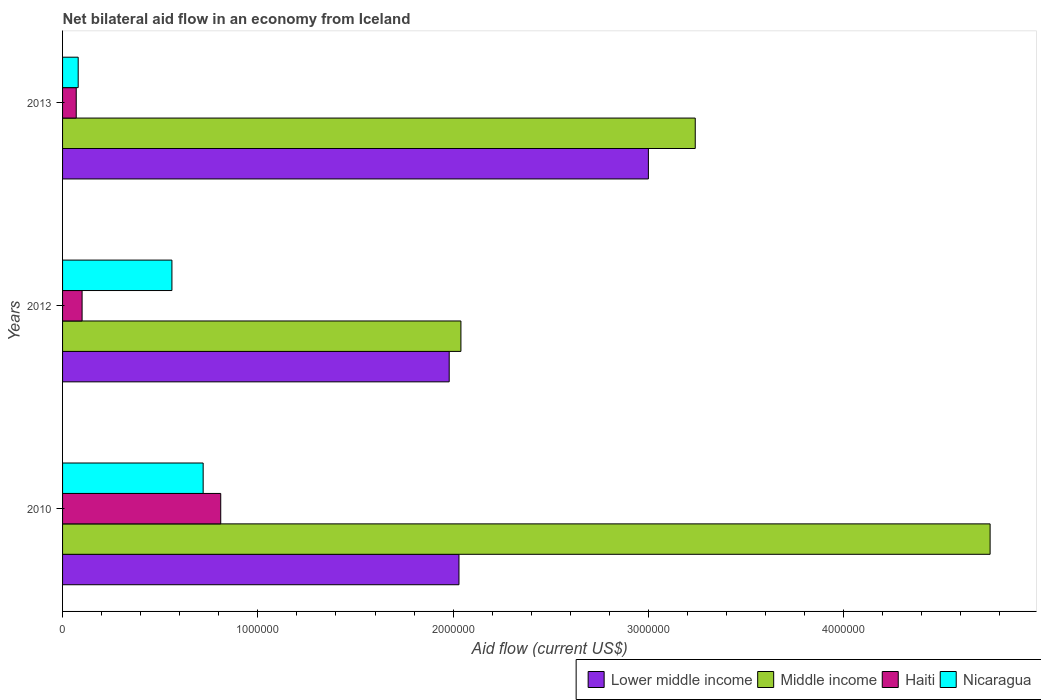Are the number of bars on each tick of the Y-axis equal?
Give a very brief answer. Yes. What is the net bilateral aid flow in Lower middle income in 2012?
Offer a terse response. 1.98e+06. Across all years, what is the maximum net bilateral aid flow in Middle income?
Offer a terse response. 4.75e+06. Across all years, what is the minimum net bilateral aid flow in Middle income?
Provide a short and direct response. 2.04e+06. In which year was the net bilateral aid flow in Nicaragua maximum?
Make the answer very short. 2010. What is the total net bilateral aid flow in Lower middle income in the graph?
Offer a terse response. 7.01e+06. What is the difference between the net bilateral aid flow in Haiti in 2012 and that in 2013?
Offer a very short reply. 3.00e+04. What is the difference between the net bilateral aid flow in Middle income in 2010 and the net bilateral aid flow in Lower middle income in 2013?
Your answer should be compact. 1.75e+06. What is the average net bilateral aid flow in Lower middle income per year?
Your response must be concise. 2.34e+06. In the year 2012, what is the difference between the net bilateral aid flow in Middle income and net bilateral aid flow in Nicaragua?
Your response must be concise. 1.48e+06. In how many years, is the net bilateral aid flow in Middle income greater than 4200000 US$?
Ensure brevity in your answer.  1. What is the ratio of the net bilateral aid flow in Lower middle income in 2012 to that in 2013?
Provide a short and direct response. 0.66. Is the difference between the net bilateral aid flow in Middle income in 2012 and 2013 greater than the difference between the net bilateral aid flow in Nicaragua in 2012 and 2013?
Your answer should be compact. No. What is the difference between the highest and the second highest net bilateral aid flow in Middle income?
Provide a short and direct response. 1.51e+06. What is the difference between the highest and the lowest net bilateral aid flow in Nicaragua?
Your answer should be very brief. 6.40e+05. What does the 4th bar from the top in 2013 represents?
Ensure brevity in your answer.  Lower middle income. What does the 1st bar from the bottom in 2010 represents?
Make the answer very short. Lower middle income. How many bars are there?
Offer a terse response. 12. How many years are there in the graph?
Your response must be concise. 3. Are the values on the major ticks of X-axis written in scientific E-notation?
Make the answer very short. No. Where does the legend appear in the graph?
Provide a succinct answer. Bottom right. How many legend labels are there?
Your answer should be very brief. 4. What is the title of the graph?
Your answer should be compact. Net bilateral aid flow in an economy from Iceland. What is the label or title of the Y-axis?
Provide a short and direct response. Years. What is the Aid flow (current US$) in Lower middle income in 2010?
Offer a very short reply. 2.03e+06. What is the Aid flow (current US$) in Middle income in 2010?
Offer a very short reply. 4.75e+06. What is the Aid flow (current US$) in Haiti in 2010?
Keep it short and to the point. 8.10e+05. What is the Aid flow (current US$) of Nicaragua in 2010?
Keep it short and to the point. 7.20e+05. What is the Aid flow (current US$) in Lower middle income in 2012?
Provide a succinct answer. 1.98e+06. What is the Aid flow (current US$) in Middle income in 2012?
Make the answer very short. 2.04e+06. What is the Aid flow (current US$) in Nicaragua in 2012?
Your answer should be compact. 5.60e+05. What is the Aid flow (current US$) of Middle income in 2013?
Keep it short and to the point. 3.24e+06. What is the Aid flow (current US$) of Nicaragua in 2013?
Keep it short and to the point. 8.00e+04. Across all years, what is the maximum Aid flow (current US$) in Middle income?
Make the answer very short. 4.75e+06. Across all years, what is the maximum Aid flow (current US$) of Haiti?
Your response must be concise. 8.10e+05. Across all years, what is the maximum Aid flow (current US$) in Nicaragua?
Offer a very short reply. 7.20e+05. Across all years, what is the minimum Aid flow (current US$) of Lower middle income?
Your response must be concise. 1.98e+06. Across all years, what is the minimum Aid flow (current US$) in Middle income?
Give a very brief answer. 2.04e+06. Across all years, what is the minimum Aid flow (current US$) in Haiti?
Keep it short and to the point. 7.00e+04. What is the total Aid flow (current US$) of Lower middle income in the graph?
Offer a very short reply. 7.01e+06. What is the total Aid flow (current US$) in Middle income in the graph?
Your response must be concise. 1.00e+07. What is the total Aid flow (current US$) in Haiti in the graph?
Provide a short and direct response. 9.80e+05. What is the total Aid flow (current US$) of Nicaragua in the graph?
Provide a short and direct response. 1.36e+06. What is the difference between the Aid flow (current US$) in Middle income in 2010 and that in 2012?
Offer a terse response. 2.71e+06. What is the difference between the Aid flow (current US$) of Haiti in 2010 and that in 2012?
Offer a very short reply. 7.10e+05. What is the difference between the Aid flow (current US$) in Nicaragua in 2010 and that in 2012?
Provide a succinct answer. 1.60e+05. What is the difference between the Aid flow (current US$) of Lower middle income in 2010 and that in 2013?
Your answer should be very brief. -9.70e+05. What is the difference between the Aid flow (current US$) of Middle income in 2010 and that in 2013?
Ensure brevity in your answer.  1.51e+06. What is the difference between the Aid flow (current US$) in Haiti in 2010 and that in 2013?
Provide a succinct answer. 7.40e+05. What is the difference between the Aid flow (current US$) of Nicaragua in 2010 and that in 2013?
Offer a terse response. 6.40e+05. What is the difference between the Aid flow (current US$) of Lower middle income in 2012 and that in 2013?
Your answer should be compact. -1.02e+06. What is the difference between the Aid flow (current US$) in Middle income in 2012 and that in 2013?
Provide a short and direct response. -1.20e+06. What is the difference between the Aid flow (current US$) in Haiti in 2012 and that in 2013?
Give a very brief answer. 3.00e+04. What is the difference between the Aid flow (current US$) of Nicaragua in 2012 and that in 2013?
Offer a very short reply. 4.80e+05. What is the difference between the Aid flow (current US$) of Lower middle income in 2010 and the Aid flow (current US$) of Haiti in 2012?
Give a very brief answer. 1.93e+06. What is the difference between the Aid flow (current US$) in Lower middle income in 2010 and the Aid flow (current US$) in Nicaragua in 2012?
Your response must be concise. 1.47e+06. What is the difference between the Aid flow (current US$) in Middle income in 2010 and the Aid flow (current US$) in Haiti in 2012?
Give a very brief answer. 4.65e+06. What is the difference between the Aid flow (current US$) in Middle income in 2010 and the Aid flow (current US$) in Nicaragua in 2012?
Make the answer very short. 4.19e+06. What is the difference between the Aid flow (current US$) of Haiti in 2010 and the Aid flow (current US$) of Nicaragua in 2012?
Your answer should be very brief. 2.50e+05. What is the difference between the Aid flow (current US$) of Lower middle income in 2010 and the Aid flow (current US$) of Middle income in 2013?
Offer a terse response. -1.21e+06. What is the difference between the Aid flow (current US$) in Lower middle income in 2010 and the Aid flow (current US$) in Haiti in 2013?
Make the answer very short. 1.96e+06. What is the difference between the Aid flow (current US$) in Lower middle income in 2010 and the Aid flow (current US$) in Nicaragua in 2013?
Provide a short and direct response. 1.95e+06. What is the difference between the Aid flow (current US$) in Middle income in 2010 and the Aid flow (current US$) in Haiti in 2013?
Give a very brief answer. 4.68e+06. What is the difference between the Aid flow (current US$) of Middle income in 2010 and the Aid flow (current US$) of Nicaragua in 2013?
Keep it short and to the point. 4.67e+06. What is the difference between the Aid flow (current US$) of Haiti in 2010 and the Aid flow (current US$) of Nicaragua in 2013?
Your answer should be compact. 7.30e+05. What is the difference between the Aid flow (current US$) of Lower middle income in 2012 and the Aid flow (current US$) of Middle income in 2013?
Your answer should be compact. -1.26e+06. What is the difference between the Aid flow (current US$) of Lower middle income in 2012 and the Aid flow (current US$) of Haiti in 2013?
Your answer should be compact. 1.91e+06. What is the difference between the Aid flow (current US$) in Lower middle income in 2012 and the Aid flow (current US$) in Nicaragua in 2013?
Provide a short and direct response. 1.90e+06. What is the difference between the Aid flow (current US$) of Middle income in 2012 and the Aid flow (current US$) of Haiti in 2013?
Your answer should be very brief. 1.97e+06. What is the difference between the Aid flow (current US$) in Middle income in 2012 and the Aid flow (current US$) in Nicaragua in 2013?
Offer a very short reply. 1.96e+06. What is the average Aid flow (current US$) in Lower middle income per year?
Ensure brevity in your answer.  2.34e+06. What is the average Aid flow (current US$) of Middle income per year?
Your answer should be compact. 3.34e+06. What is the average Aid flow (current US$) in Haiti per year?
Make the answer very short. 3.27e+05. What is the average Aid flow (current US$) in Nicaragua per year?
Give a very brief answer. 4.53e+05. In the year 2010, what is the difference between the Aid flow (current US$) of Lower middle income and Aid flow (current US$) of Middle income?
Your answer should be very brief. -2.72e+06. In the year 2010, what is the difference between the Aid flow (current US$) in Lower middle income and Aid flow (current US$) in Haiti?
Your answer should be compact. 1.22e+06. In the year 2010, what is the difference between the Aid flow (current US$) in Lower middle income and Aid flow (current US$) in Nicaragua?
Provide a succinct answer. 1.31e+06. In the year 2010, what is the difference between the Aid flow (current US$) of Middle income and Aid flow (current US$) of Haiti?
Give a very brief answer. 3.94e+06. In the year 2010, what is the difference between the Aid flow (current US$) in Middle income and Aid flow (current US$) in Nicaragua?
Provide a succinct answer. 4.03e+06. In the year 2010, what is the difference between the Aid flow (current US$) in Haiti and Aid flow (current US$) in Nicaragua?
Give a very brief answer. 9.00e+04. In the year 2012, what is the difference between the Aid flow (current US$) of Lower middle income and Aid flow (current US$) of Middle income?
Keep it short and to the point. -6.00e+04. In the year 2012, what is the difference between the Aid flow (current US$) of Lower middle income and Aid flow (current US$) of Haiti?
Your answer should be very brief. 1.88e+06. In the year 2012, what is the difference between the Aid flow (current US$) in Lower middle income and Aid flow (current US$) in Nicaragua?
Give a very brief answer. 1.42e+06. In the year 2012, what is the difference between the Aid flow (current US$) in Middle income and Aid flow (current US$) in Haiti?
Your response must be concise. 1.94e+06. In the year 2012, what is the difference between the Aid flow (current US$) in Middle income and Aid flow (current US$) in Nicaragua?
Make the answer very short. 1.48e+06. In the year 2012, what is the difference between the Aid flow (current US$) in Haiti and Aid flow (current US$) in Nicaragua?
Ensure brevity in your answer.  -4.60e+05. In the year 2013, what is the difference between the Aid flow (current US$) of Lower middle income and Aid flow (current US$) of Middle income?
Give a very brief answer. -2.40e+05. In the year 2013, what is the difference between the Aid flow (current US$) in Lower middle income and Aid flow (current US$) in Haiti?
Your response must be concise. 2.93e+06. In the year 2013, what is the difference between the Aid flow (current US$) of Lower middle income and Aid flow (current US$) of Nicaragua?
Provide a short and direct response. 2.92e+06. In the year 2013, what is the difference between the Aid flow (current US$) in Middle income and Aid flow (current US$) in Haiti?
Provide a succinct answer. 3.17e+06. In the year 2013, what is the difference between the Aid flow (current US$) in Middle income and Aid flow (current US$) in Nicaragua?
Provide a short and direct response. 3.16e+06. In the year 2013, what is the difference between the Aid flow (current US$) in Haiti and Aid flow (current US$) in Nicaragua?
Offer a very short reply. -10000. What is the ratio of the Aid flow (current US$) in Lower middle income in 2010 to that in 2012?
Make the answer very short. 1.03. What is the ratio of the Aid flow (current US$) in Middle income in 2010 to that in 2012?
Your response must be concise. 2.33. What is the ratio of the Aid flow (current US$) of Lower middle income in 2010 to that in 2013?
Give a very brief answer. 0.68. What is the ratio of the Aid flow (current US$) in Middle income in 2010 to that in 2013?
Make the answer very short. 1.47. What is the ratio of the Aid flow (current US$) of Haiti in 2010 to that in 2013?
Ensure brevity in your answer.  11.57. What is the ratio of the Aid flow (current US$) of Lower middle income in 2012 to that in 2013?
Keep it short and to the point. 0.66. What is the ratio of the Aid flow (current US$) in Middle income in 2012 to that in 2013?
Offer a very short reply. 0.63. What is the ratio of the Aid flow (current US$) of Haiti in 2012 to that in 2013?
Ensure brevity in your answer.  1.43. What is the difference between the highest and the second highest Aid flow (current US$) in Lower middle income?
Ensure brevity in your answer.  9.70e+05. What is the difference between the highest and the second highest Aid flow (current US$) of Middle income?
Offer a terse response. 1.51e+06. What is the difference between the highest and the second highest Aid flow (current US$) in Haiti?
Keep it short and to the point. 7.10e+05. What is the difference between the highest and the lowest Aid flow (current US$) of Lower middle income?
Make the answer very short. 1.02e+06. What is the difference between the highest and the lowest Aid flow (current US$) in Middle income?
Offer a terse response. 2.71e+06. What is the difference between the highest and the lowest Aid flow (current US$) in Haiti?
Your answer should be compact. 7.40e+05. What is the difference between the highest and the lowest Aid flow (current US$) of Nicaragua?
Provide a short and direct response. 6.40e+05. 